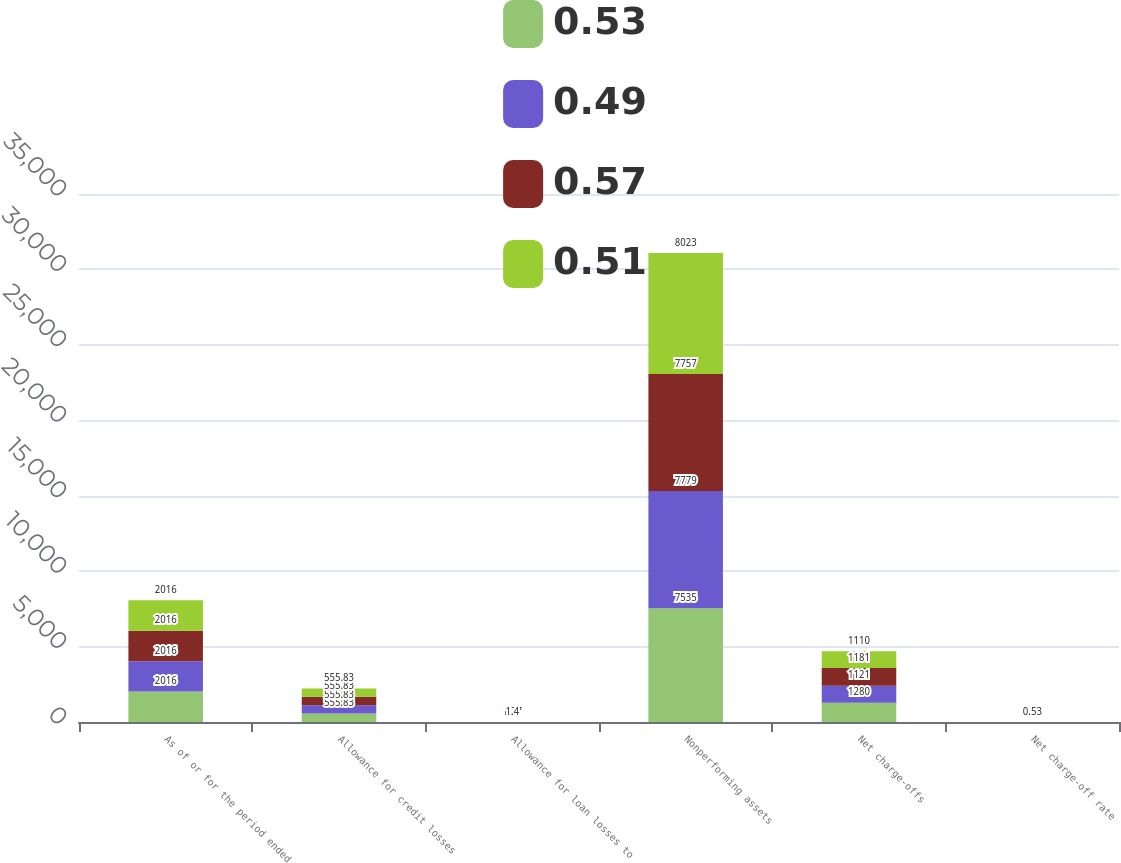Convert chart. <chart><loc_0><loc_0><loc_500><loc_500><stacked_bar_chart><ecel><fcel>As of or for the period ended<fcel>Allowance for credit losses<fcel>Allowance for loan losses to<fcel>Nonperforming assets<fcel>Net charge-offs<fcel>Net charge-off rate<nl><fcel>0.53<fcel>2016<fcel>555.83<fcel>1.34<fcel>7535<fcel>1280<fcel>0.58<nl><fcel>0.49<fcel>2016<fcel>555.83<fcel>1.37<fcel>7779<fcel>1121<fcel>0.51<nl><fcel>0.57<fcel>2016<fcel>555.83<fcel>1.4<fcel>7757<fcel>1181<fcel>0.56<nl><fcel>0.51<fcel>2016<fcel>555.83<fcel>1.4<fcel>8023<fcel>1110<fcel>0.53<nl></chart> 